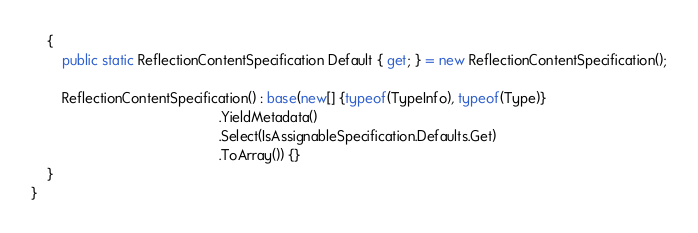Convert code to text. <code><loc_0><loc_0><loc_500><loc_500><_C#_>	{
		public static ReflectionContentSpecification Default { get; } = new ReflectionContentSpecification();

		ReflectionContentSpecification() : base(new[] {typeof(TypeInfo), typeof(Type)}
		                                        .YieldMetadata()
		                                        .Select(IsAssignableSpecification.Defaults.Get)
		                                        .ToArray()) {}
	}
}</code> 